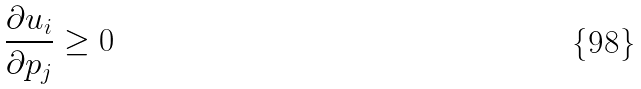<formula> <loc_0><loc_0><loc_500><loc_500>\frac { \partial u _ { i } } { \partial p _ { j } } \geq 0</formula> 